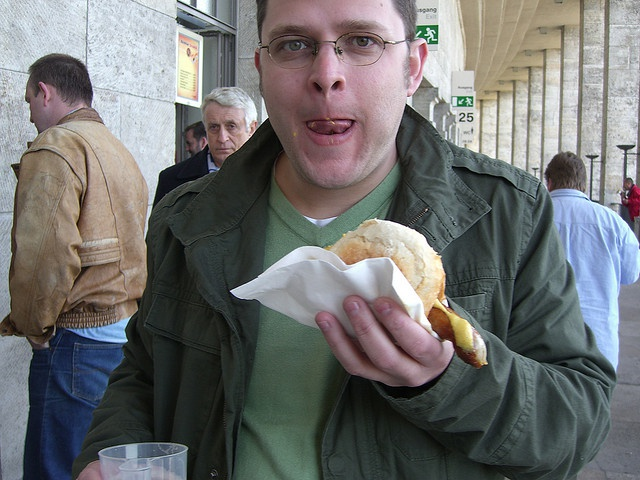Describe the objects in this image and their specific colors. I can see people in lightgray, black, gray, and darkgray tones, people in lightgray, darkgray, gray, and black tones, people in lightgray, lightblue, and gray tones, hot dog in lightgray, ivory, and tan tones, and people in lightgray, black, darkgray, and gray tones in this image. 